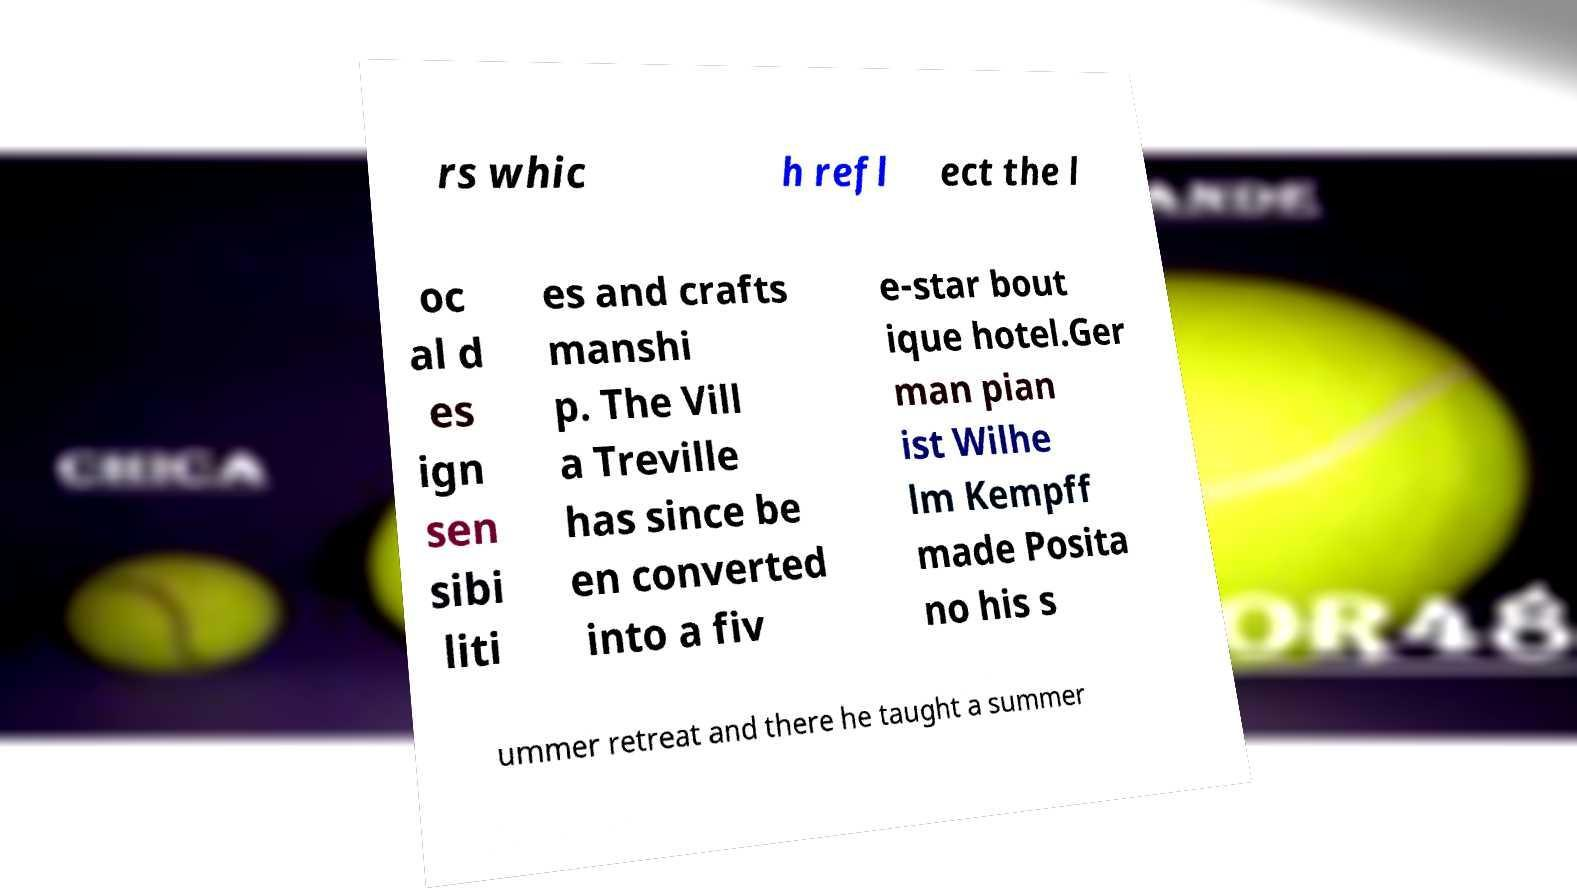Could you assist in decoding the text presented in this image and type it out clearly? rs whic h refl ect the l oc al d es ign sen sibi liti es and crafts manshi p. The Vill a Treville has since be en converted into a fiv e-star bout ique hotel.Ger man pian ist Wilhe lm Kempff made Posita no his s ummer retreat and there he taught a summer 